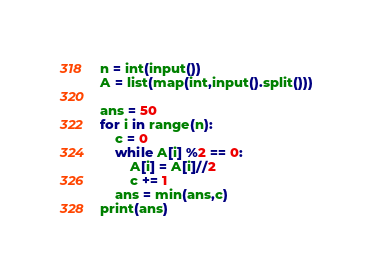Convert code to text. <code><loc_0><loc_0><loc_500><loc_500><_Python_>n = int(input())
A = list(map(int,input().split()))

ans = 50
for i in range(n):
    c = 0
    while A[i] %2 == 0:
        A[i] = A[i]//2
        c += 1
    ans = min(ans,c)
print(ans)
</code> 